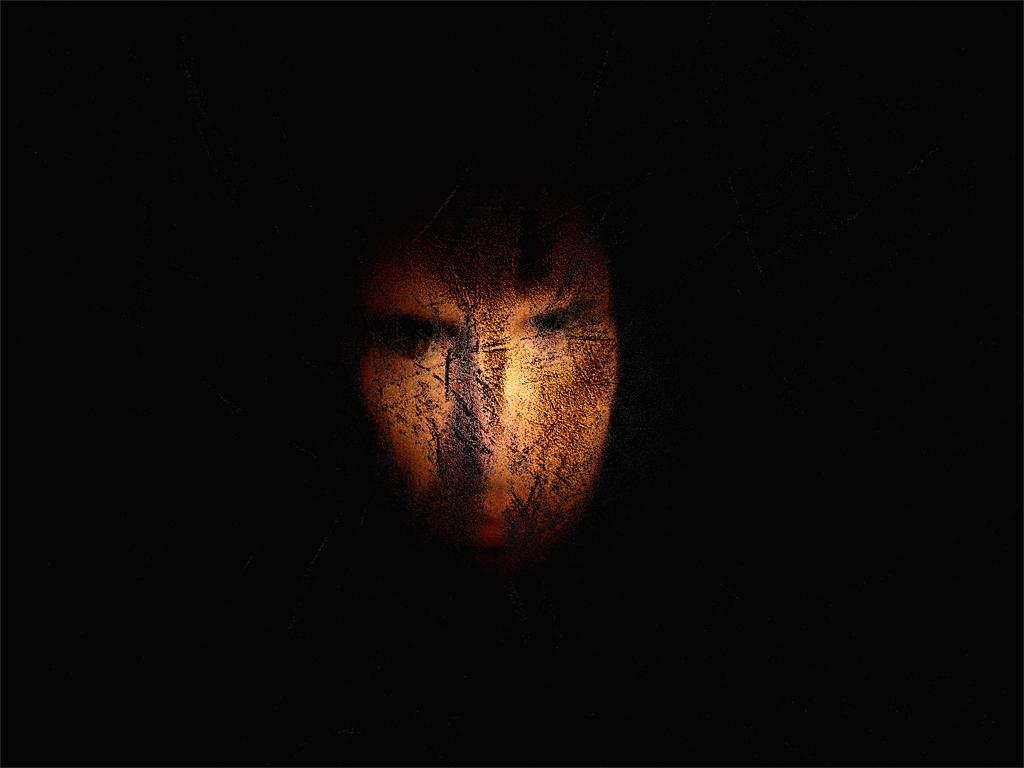What object is the main focus of the image? There is a mask in the image. How would you describe the appearance of the mask? The mask is full of scars. What is the overall tone or color of the image? The image surrounding the mask is dark. What type of beam is holding up the mask in the image? There is no beam present in the image; the mask is not being held up by any visible support. 